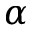<formula> <loc_0><loc_0><loc_500><loc_500>\alpha</formula> 